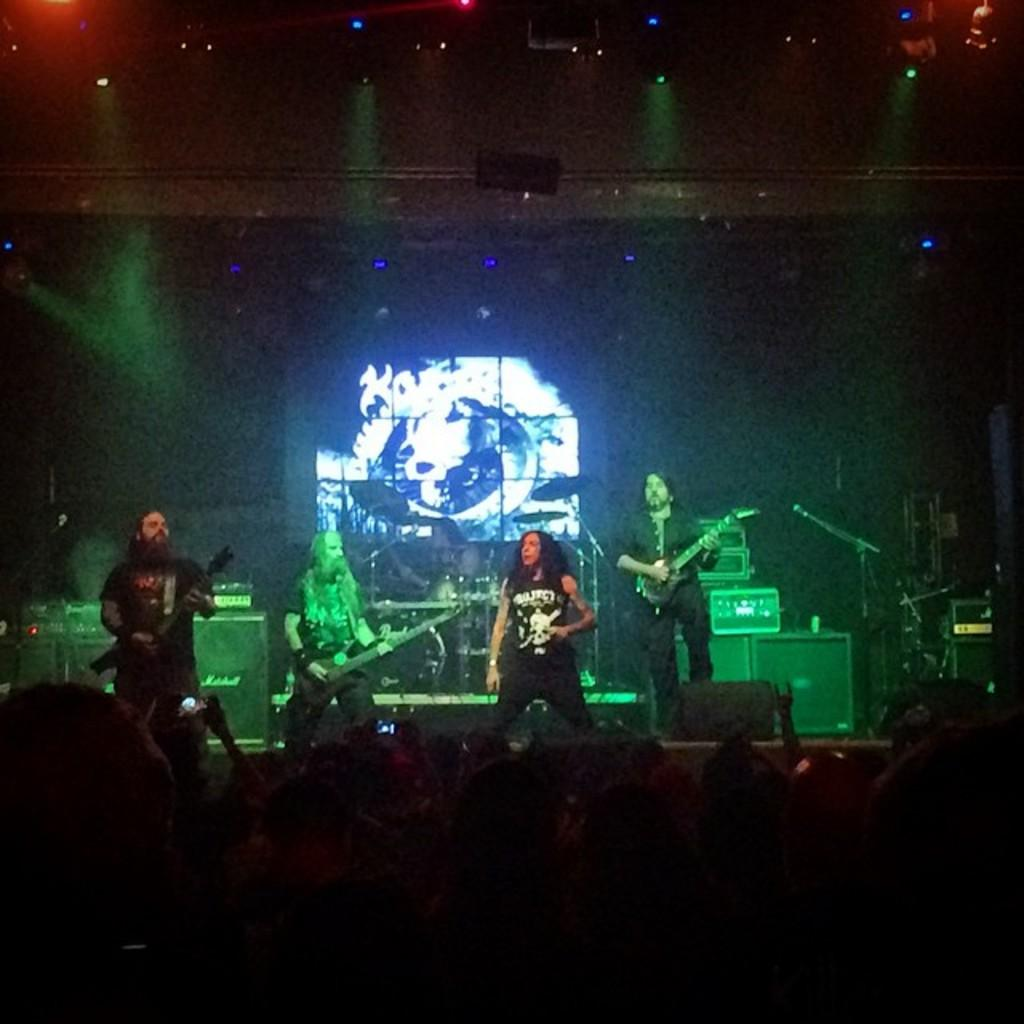How many people are in the image? There is a group of people in the image. Where are some of the people located in the image? Some people are on stage. What are the people on stage doing? The people on stage are playing guitars and drums. What equipment is present for amplifying sound? There are microphones (mics) present. What type of objects can be seen stacked or stored? There are boxes visible. What can be seen in the background of the image? There are lights in the background. How would you describe the lighting conditions in the image? The background is dark. What type of toothbrush is being used by the person on stage? There is no toothbrush present in the image. What color is the sheet draped over the drum set? There is no sheet draped over the drum set in the image. 